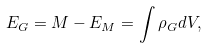Convert formula to latex. <formula><loc_0><loc_0><loc_500><loc_500>E _ { G } = M - E _ { M } = \int \rho _ { G } d V ,</formula> 